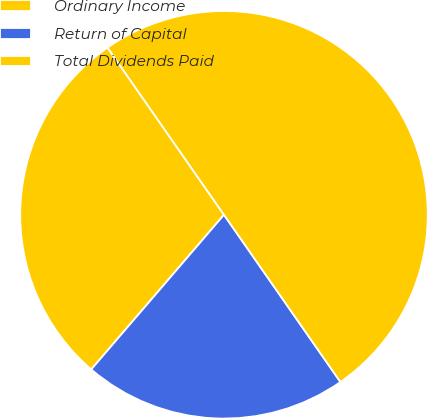Convert chart to OTSL. <chart><loc_0><loc_0><loc_500><loc_500><pie_chart><fcel>Ordinary Income<fcel>Return of Capital<fcel>Total Dividends Paid<nl><fcel>29.03%<fcel>20.97%<fcel>50.0%<nl></chart> 